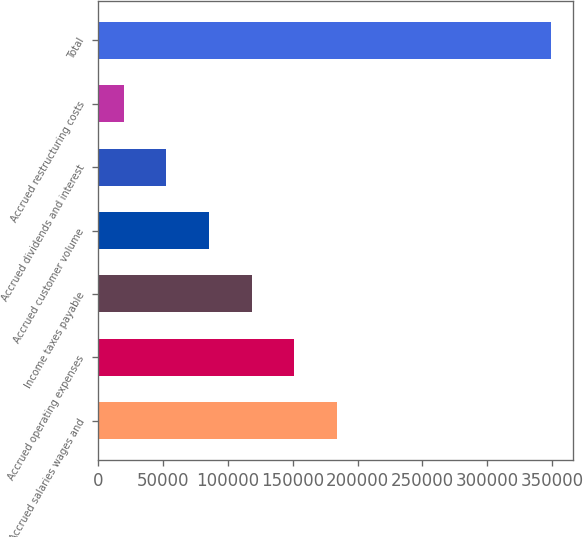Convert chart. <chart><loc_0><loc_0><loc_500><loc_500><bar_chart><fcel>Accrued salaries wages and<fcel>Accrued operating expenses<fcel>Income taxes payable<fcel>Accrued customer volume<fcel>Accrued dividends and interest<fcel>Accrued restructuring costs<fcel>Total<nl><fcel>184278<fcel>151362<fcel>118446<fcel>85529.4<fcel>52613.2<fcel>19697<fcel>348859<nl></chart> 